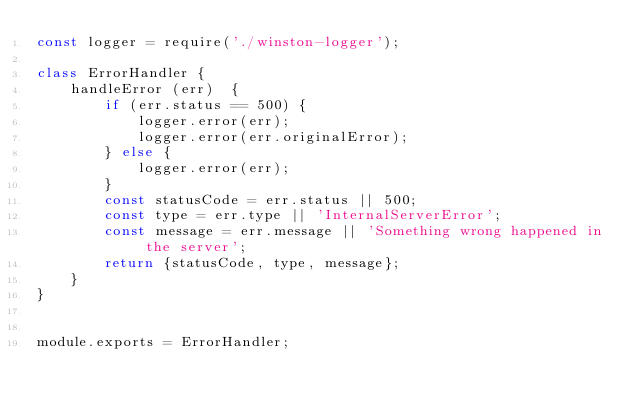Convert code to text. <code><loc_0><loc_0><loc_500><loc_500><_JavaScript_>const logger = require('./winston-logger');

class ErrorHandler {
    handleError (err)  {
        if (err.status == 500) {
            logger.error(err);
            logger.error(err.originalError);
        } else {
            logger.error(err);
        }
        const statusCode = err.status || 500;
        const type = err.type || 'InternalServerError';
        const message = err.message || 'Something wrong happened in the server';
        return {statusCode, type, message};
    }
}


module.exports = ErrorHandler;</code> 